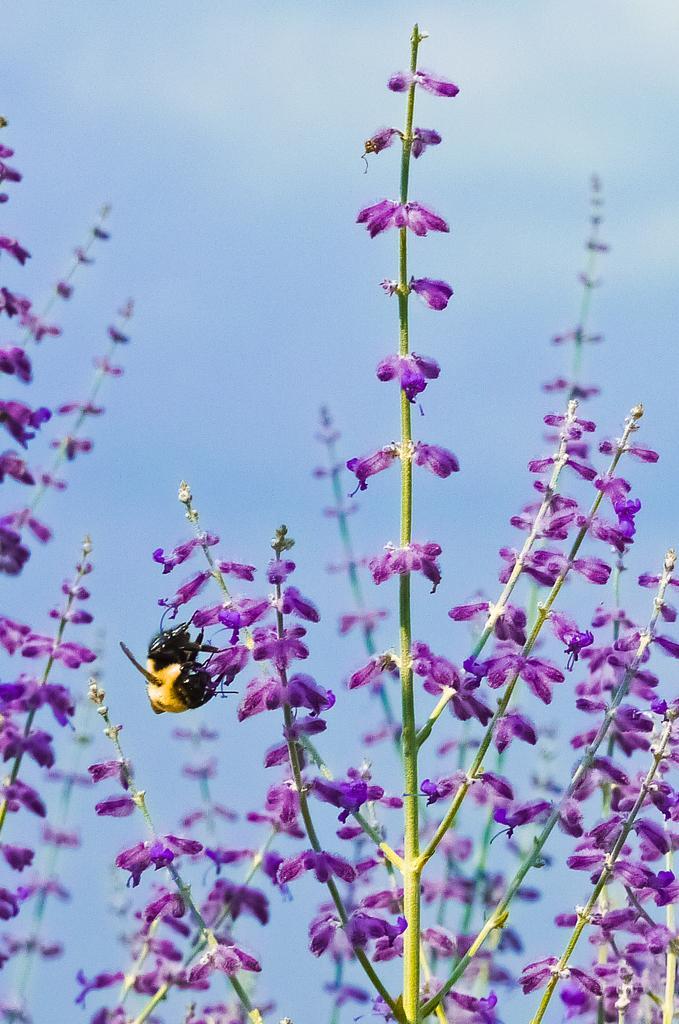Please provide a concise description of this image. In this picture in the front there is a bee and there are flowers. 